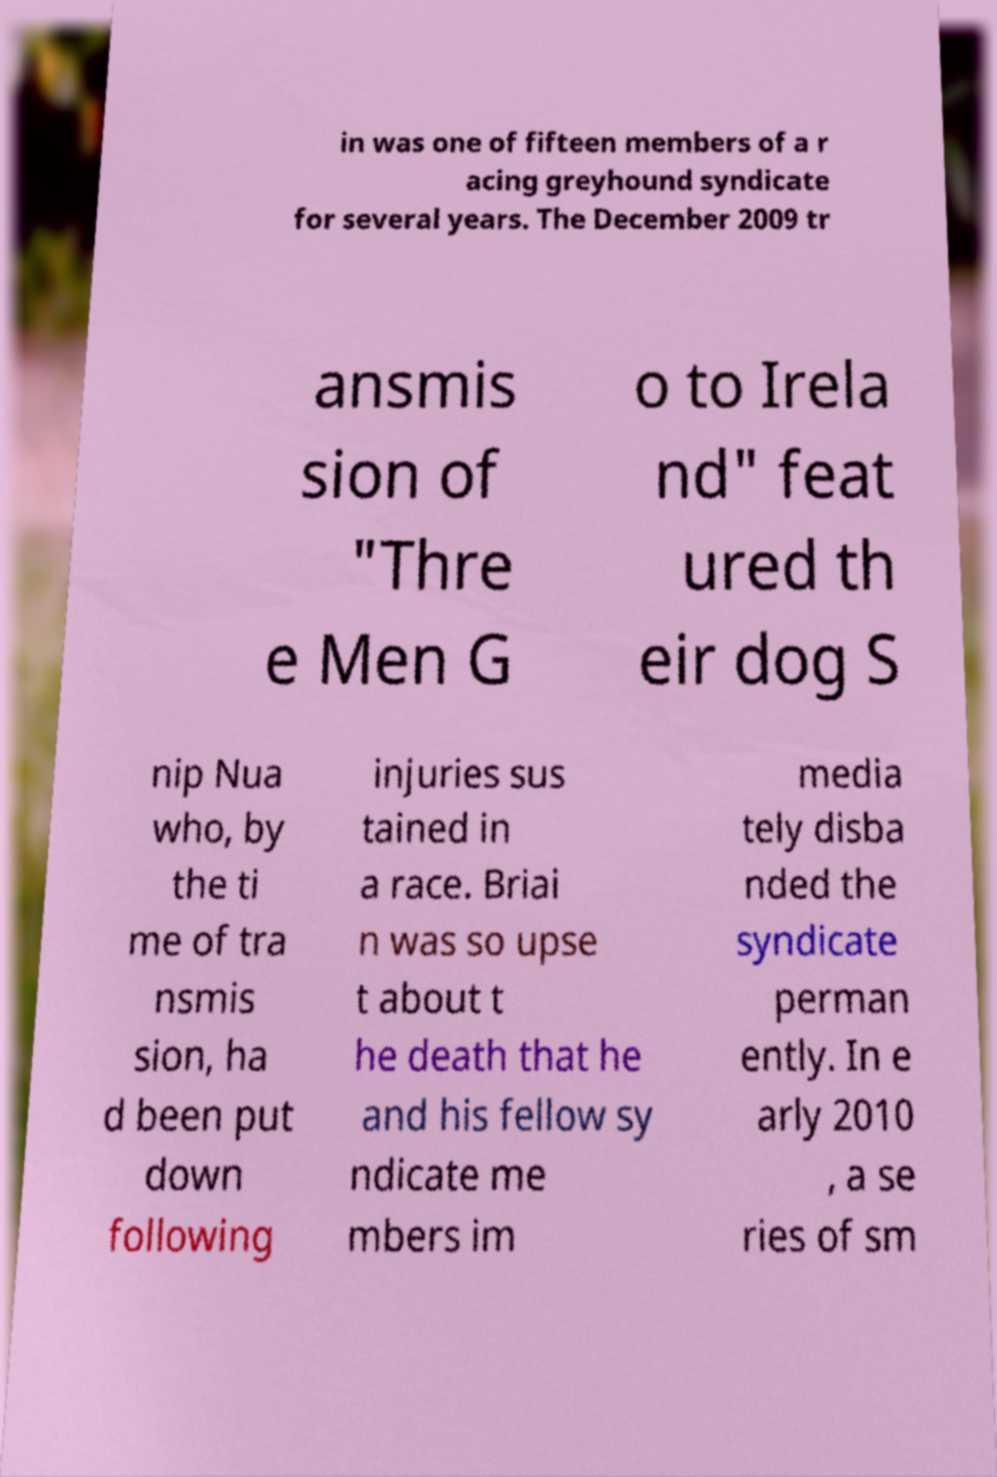What messages or text are displayed in this image? I need them in a readable, typed format. in was one of fifteen members of a r acing greyhound syndicate for several years. The December 2009 tr ansmis sion of "Thre e Men G o to Irela nd" feat ured th eir dog S nip Nua who, by the ti me of tra nsmis sion, ha d been put down following injuries sus tained in a race. Briai n was so upse t about t he death that he and his fellow sy ndicate me mbers im media tely disba nded the syndicate perman ently. In e arly 2010 , a se ries of sm 